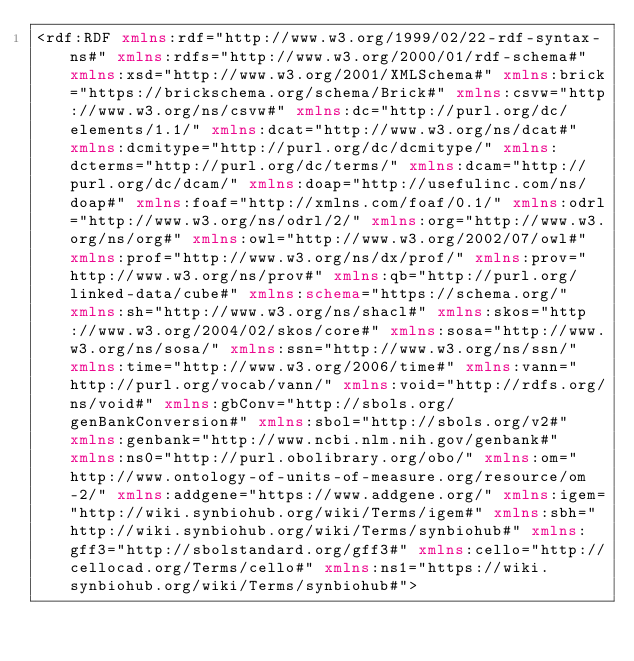Convert code to text. <code><loc_0><loc_0><loc_500><loc_500><_XML_><rdf:RDF xmlns:rdf="http://www.w3.org/1999/02/22-rdf-syntax-ns#" xmlns:rdfs="http://www.w3.org/2000/01/rdf-schema#" xmlns:xsd="http://www.w3.org/2001/XMLSchema#" xmlns:brick="https://brickschema.org/schema/Brick#" xmlns:csvw="http://www.w3.org/ns/csvw#" xmlns:dc="http://purl.org/dc/elements/1.1/" xmlns:dcat="http://www.w3.org/ns/dcat#" xmlns:dcmitype="http://purl.org/dc/dcmitype/" xmlns:dcterms="http://purl.org/dc/terms/" xmlns:dcam="http://purl.org/dc/dcam/" xmlns:doap="http://usefulinc.com/ns/doap#" xmlns:foaf="http://xmlns.com/foaf/0.1/" xmlns:odrl="http://www.w3.org/ns/odrl/2/" xmlns:org="http://www.w3.org/ns/org#" xmlns:owl="http://www.w3.org/2002/07/owl#" xmlns:prof="http://www.w3.org/ns/dx/prof/" xmlns:prov="http://www.w3.org/ns/prov#" xmlns:qb="http://purl.org/linked-data/cube#" xmlns:schema="https://schema.org/" xmlns:sh="http://www.w3.org/ns/shacl#" xmlns:skos="http://www.w3.org/2004/02/skos/core#" xmlns:sosa="http://www.w3.org/ns/sosa/" xmlns:ssn="http://www.w3.org/ns/ssn/" xmlns:time="http://www.w3.org/2006/time#" xmlns:vann="http://purl.org/vocab/vann/" xmlns:void="http://rdfs.org/ns/void#" xmlns:gbConv="http://sbols.org/genBankConversion#" xmlns:sbol="http://sbols.org/v2#" xmlns:genbank="http://www.ncbi.nlm.nih.gov/genbank#" xmlns:ns0="http://purl.obolibrary.org/obo/" xmlns:om="http://www.ontology-of-units-of-measure.org/resource/om-2/" xmlns:addgene="https://www.addgene.org/" xmlns:igem="http://wiki.synbiohub.org/wiki/Terms/igem#" xmlns:sbh="http://wiki.synbiohub.org/wiki/Terms/synbiohub#" xmlns:gff3="http://sbolstandard.org/gff3#" xmlns:cello="http://cellocad.org/Terms/cello#" xmlns:ns1="https://wiki.synbiohub.org/wiki/Terms/synbiohub#"></code> 